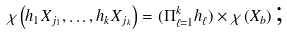<formula> <loc_0><loc_0><loc_500><loc_500>\chi \left ( h _ { 1 } X _ { j _ { 1 } } , \dots , h _ { k } X _ { j _ { k } } \right ) = ( \Pi _ { \ell = 1 } ^ { k } h _ { \ell } ) \times \chi \left ( X _ { b } \right ) \text {;}</formula> 